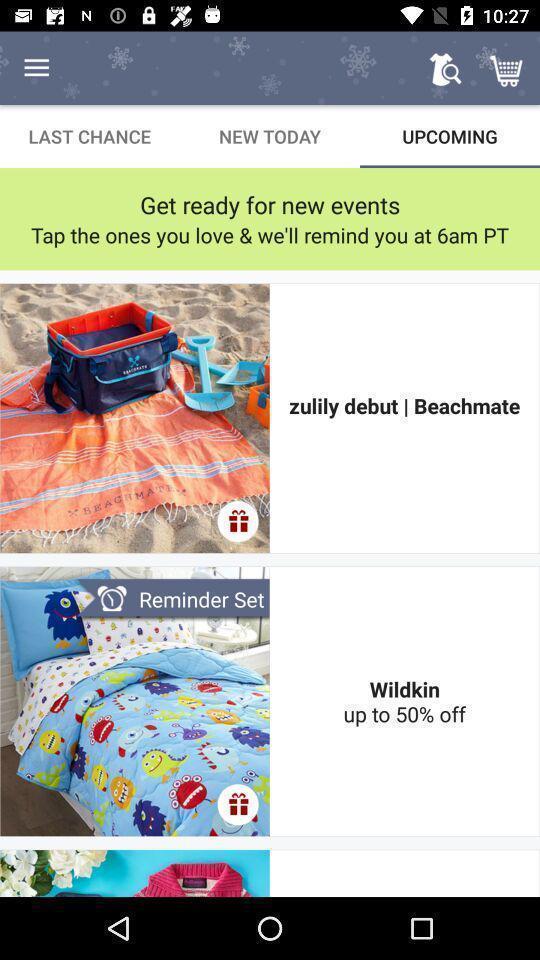Explain the elements present in this screenshot. Screen displaying the upcoming products in a shopping app. 